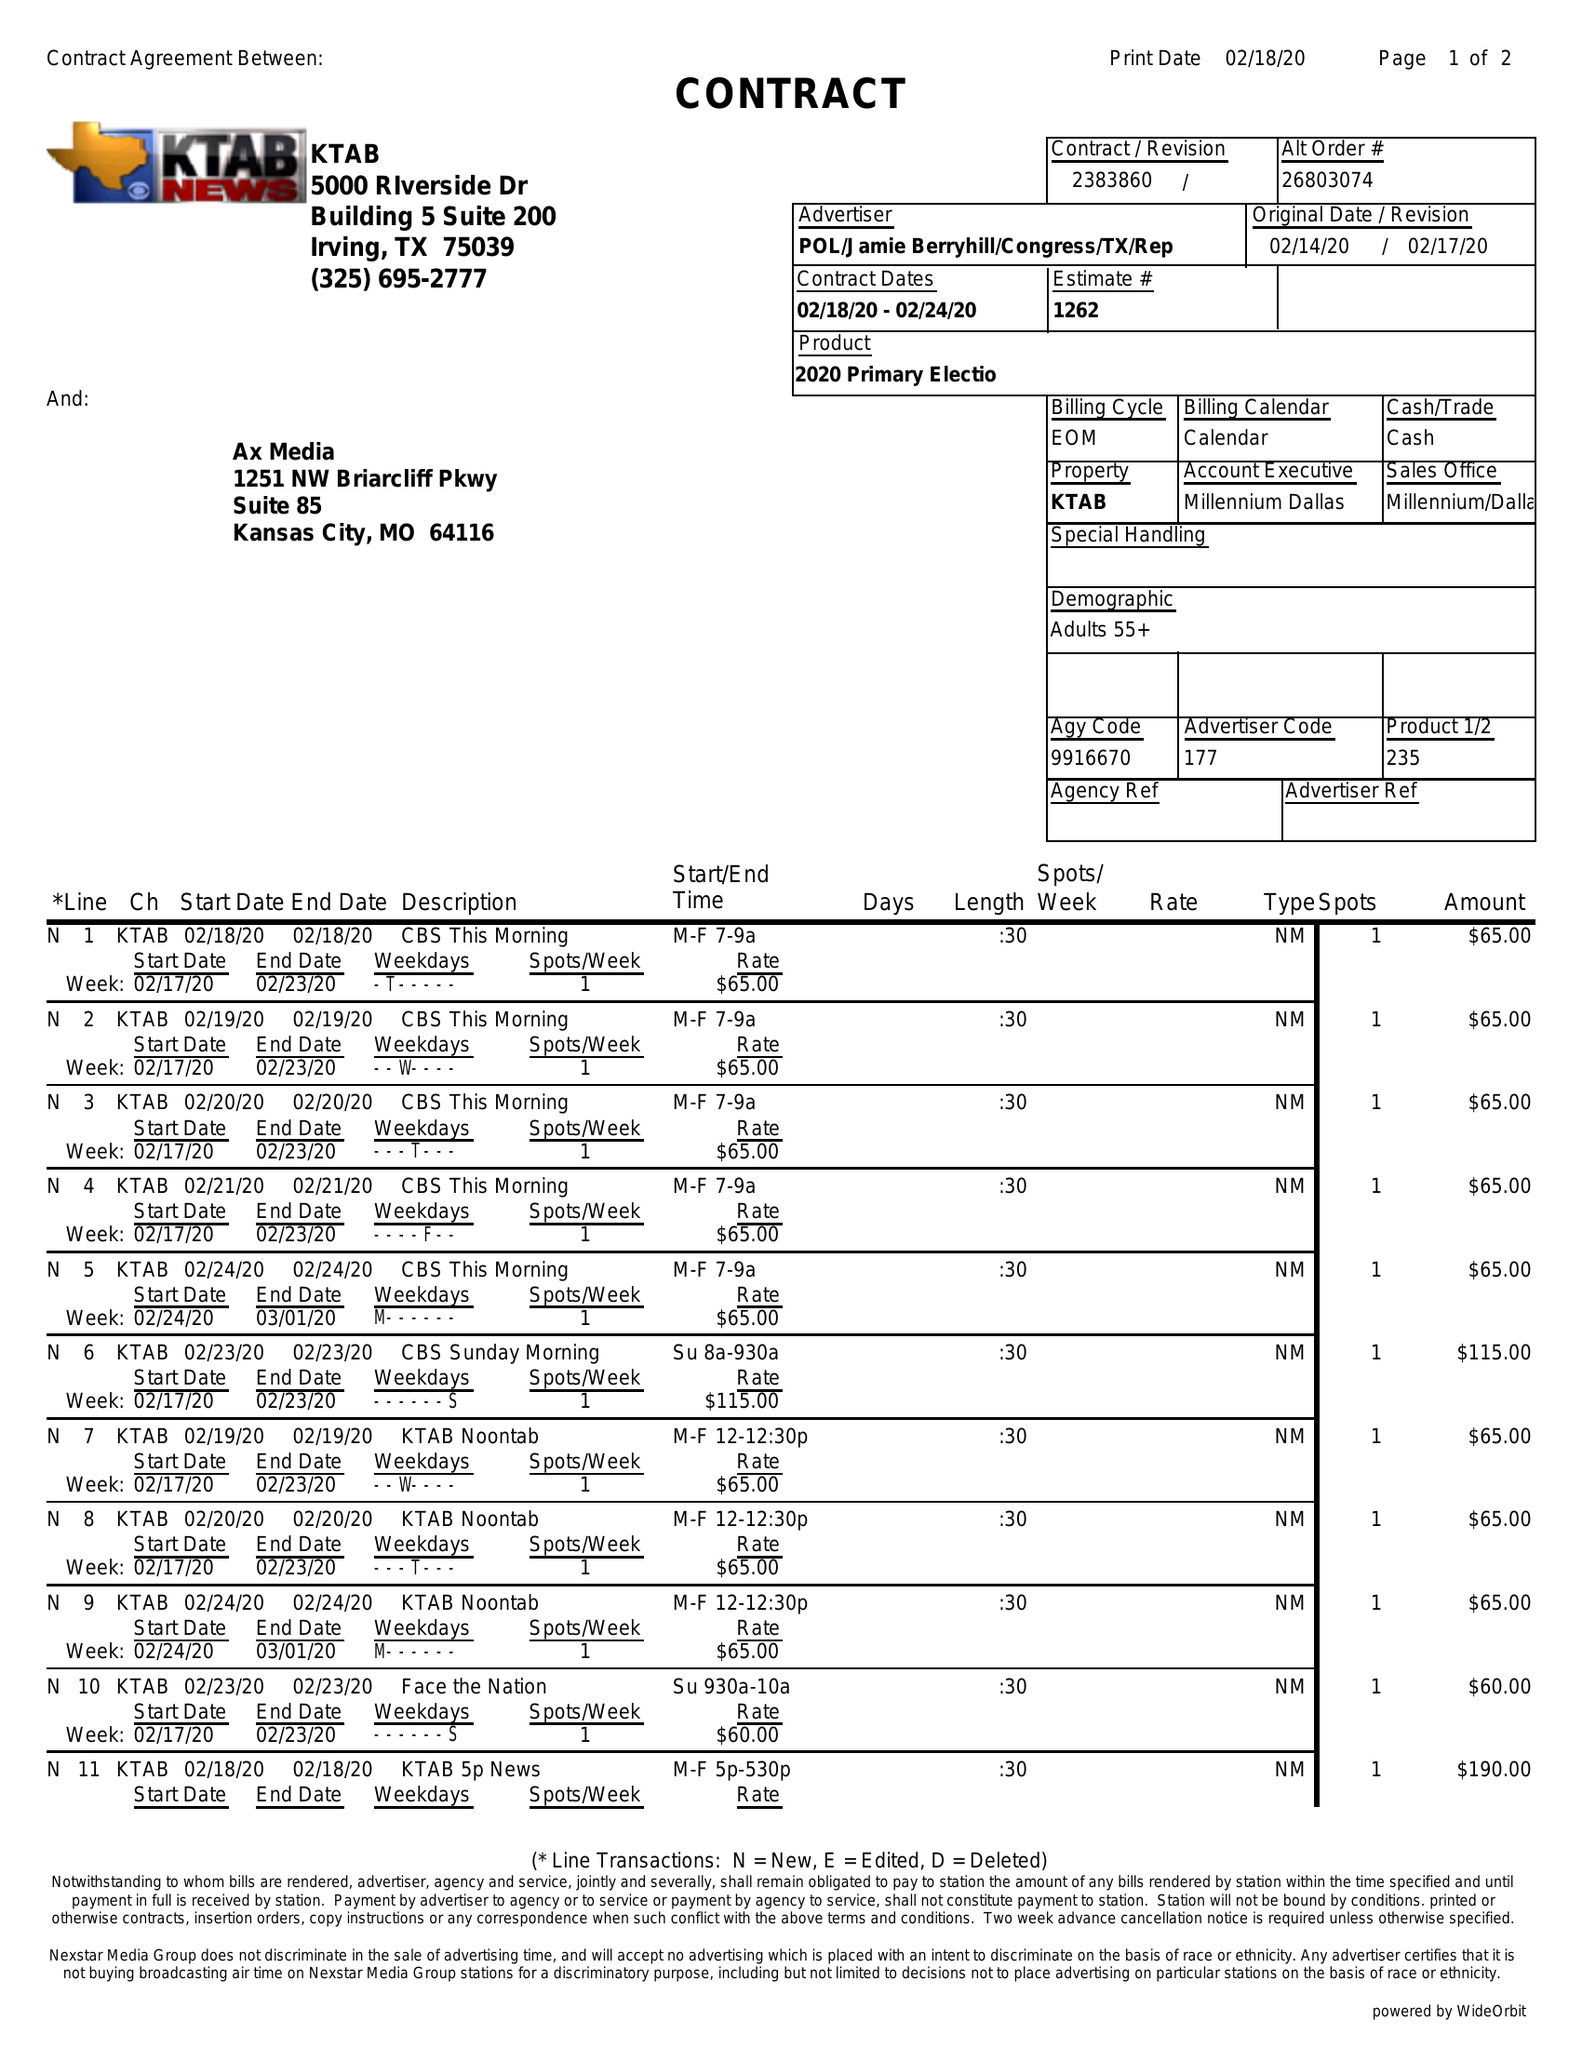What is the value for the flight_to?
Answer the question using a single word or phrase. 02/24/20 